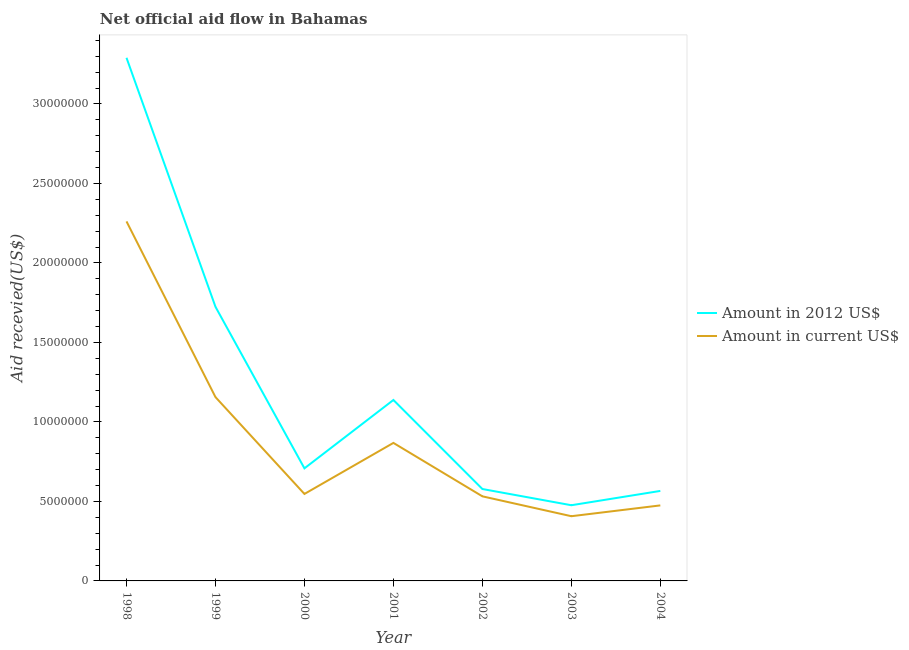Is the number of lines equal to the number of legend labels?
Keep it short and to the point. Yes. What is the amount of aid received(expressed in us$) in 2003?
Keep it short and to the point. 4.07e+06. Across all years, what is the maximum amount of aid received(expressed in 2012 us$)?
Offer a terse response. 3.29e+07. Across all years, what is the minimum amount of aid received(expressed in us$)?
Your answer should be compact. 4.07e+06. In which year was the amount of aid received(expressed in us$) maximum?
Your answer should be very brief. 1998. What is the total amount of aid received(expressed in us$) in the graph?
Provide a succinct answer. 6.25e+07. What is the difference between the amount of aid received(expressed in us$) in 1999 and that in 2004?
Provide a short and direct response. 6.81e+06. What is the difference between the amount of aid received(expressed in 2012 us$) in 1998 and the amount of aid received(expressed in us$) in 2002?
Offer a very short reply. 2.76e+07. What is the average amount of aid received(expressed in 2012 us$) per year?
Your answer should be compact. 1.21e+07. In the year 2001, what is the difference between the amount of aid received(expressed in us$) and amount of aid received(expressed in 2012 us$)?
Your response must be concise. -2.70e+06. What is the ratio of the amount of aid received(expressed in 2012 us$) in 1998 to that in 2002?
Ensure brevity in your answer.  5.69. Is the difference between the amount of aid received(expressed in us$) in 2000 and 2002 greater than the difference between the amount of aid received(expressed in 2012 us$) in 2000 and 2002?
Make the answer very short. No. What is the difference between the highest and the second highest amount of aid received(expressed in us$)?
Make the answer very short. 1.10e+07. What is the difference between the highest and the lowest amount of aid received(expressed in 2012 us$)?
Keep it short and to the point. 2.81e+07. In how many years, is the amount of aid received(expressed in 2012 us$) greater than the average amount of aid received(expressed in 2012 us$) taken over all years?
Provide a succinct answer. 2. Is the sum of the amount of aid received(expressed in us$) in 1998 and 2003 greater than the maximum amount of aid received(expressed in 2012 us$) across all years?
Keep it short and to the point. No. Is the amount of aid received(expressed in us$) strictly less than the amount of aid received(expressed in 2012 us$) over the years?
Make the answer very short. Yes. What is the difference between two consecutive major ticks on the Y-axis?
Make the answer very short. 5.00e+06. Does the graph contain any zero values?
Your answer should be very brief. No. Where does the legend appear in the graph?
Provide a short and direct response. Center right. What is the title of the graph?
Ensure brevity in your answer.  Net official aid flow in Bahamas. What is the label or title of the X-axis?
Offer a very short reply. Year. What is the label or title of the Y-axis?
Provide a succinct answer. Aid recevied(US$). What is the Aid recevied(US$) of Amount in 2012 US$ in 1998?
Your answer should be compact. 3.29e+07. What is the Aid recevied(US$) of Amount in current US$ in 1998?
Give a very brief answer. 2.26e+07. What is the Aid recevied(US$) of Amount in 2012 US$ in 1999?
Offer a terse response. 1.72e+07. What is the Aid recevied(US$) in Amount in current US$ in 1999?
Your answer should be very brief. 1.16e+07. What is the Aid recevied(US$) of Amount in 2012 US$ in 2000?
Make the answer very short. 7.08e+06. What is the Aid recevied(US$) of Amount in current US$ in 2000?
Your response must be concise. 5.47e+06. What is the Aid recevied(US$) in Amount in 2012 US$ in 2001?
Ensure brevity in your answer.  1.14e+07. What is the Aid recevied(US$) of Amount in current US$ in 2001?
Make the answer very short. 8.68e+06. What is the Aid recevied(US$) in Amount in 2012 US$ in 2002?
Your answer should be very brief. 5.78e+06. What is the Aid recevied(US$) of Amount in current US$ in 2002?
Your answer should be compact. 5.32e+06. What is the Aid recevied(US$) of Amount in 2012 US$ in 2003?
Ensure brevity in your answer.  4.76e+06. What is the Aid recevied(US$) in Amount in current US$ in 2003?
Provide a short and direct response. 4.07e+06. What is the Aid recevied(US$) in Amount in 2012 US$ in 2004?
Provide a short and direct response. 5.66e+06. What is the Aid recevied(US$) in Amount in current US$ in 2004?
Your answer should be very brief. 4.75e+06. Across all years, what is the maximum Aid recevied(US$) in Amount in 2012 US$?
Provide a succinct answer. 3.29e+07. Across all years, what is the maximum Aid recevied(US$) in Amount in current US$?
Give a very brief answer. 2.26e+07. Across all years, what is the minimum Aid recevied(US$) of Amount in 2012 US$?
Keep it short and to the point. 4.76e+06. Across all years, what is the minimum Aid recevied(US$) of Amount in current US$?
Offer a very short reply. 4.07e+06. What is the total Aid recevied(US$) of Amount in 2012 US$ in the graph?
Keep it short and to the point. 8.48e+07. What is the total Aid recevied(US$) in Amount in current US$ in the graph?
Make the answer very short. 6.25e+07. What is the difference between the Aid recevied(US$) of Amount in 2012 US$ in 1998 and that in 1999?
Your response must be concise. 1.57e+07. What is the difference between the Aid recevied(US$) of Amount in current US$ in 1998 and that in 1999?
Make the answer very short. 1.10e+07. What is the difference between the Aid recevied(US$) in Amount in 2012 US$ in 1998 and that in 2000?
Offer a terse response. 2.58e+07. What is the difference between the Aid recevied(US$) of Amount in current US$ in 1998 and that in 2000?
Offer a very short reply. 1.71e+07. What is the difference between the Aid recevied(US$) of Amount in 2012 US$ in 1998 and that in 2001?
Give a very brief answer. 2.15e+07. What is the difference between the Aid recevied(US$) in Amount in current US$ in 1998 and that in 2001?
Provide a short and direct response. 1.39e+07. What is the difference between the Aid recevied(US$) in Amount in 2012 US$ in 1998 and that in 2002?
Offer a very short reply. 2.71e+07. What is the difference between the Aid recevied(US$) in Amount in current US$ in 1998 and that in 2002?
Keep it short and to the point. 1.73e+07. What is the difference between the Aid recevied(US$) in Amount in 2012 US$ in 1998 and that in 2003?
Provide a succinct answer. 2.81e+07. What is the difference between the Aid recevied(US$) in Amount in current US$ in 1998 and that in 2003?
Make the answer very short. 1.85e+07. What is the difference between the Aid recevied(US$) of Amount in 2012 US$ in 1998 and that in 2004?
Make the answer very short. 2.72e+07. What is the difference between the Aid recevied(US$) in Amount in current US$ in 1998 and that in 2004?
Your response must be concise. 1.79e+07. What is the difference between the Aid recevied(US$) of Amount in 2012 US$ in 1999 and that in 2000?
Provide a short and direct response. 1.02e+07. What is the difference between the Aid recevied(US$) of Amount in current US$ in 1999 and that in 2000?
Keep it short and to the point. 6.09e+06. What is the difference between the Aid recevied(US$) of Amount in 2012 US$ in 1999 and that in 2001?
Make the answer very short. 5.86e+06. What is the difference between the Aid recevied(US$) in Amount in current US$ in 1999 and that in 2001?
Provide a short and direct response. 2.88e+06. What is the difference between the Aid recevied(US$) in Amount in 2012 US$ in 1999 and that in 2002?
Keep it short and to the point. 1.15e+07. What is the difference between the Aid recevied(US$) of Amount in current US$ in 1999 and that in 2002?
Offer a very short reply. 6.24e+06. What is the difference between the Aid recevied(US$) of Amount in 2012 US$ in 1999 and that in 2003?
Your answer should be very brief. 1.25e+07. What is the difference between the Aid recevied(US$) of Amount in current US$ in 1999 and that in 2003?
Provide a succinct answer. 7.49e+06. What is the difference between the Aid recevied(US$) of Amount in 2012 US$ in 1999 and that in 2004?
Ensure brevity in your answer.  1.16e+07. What is the difference between the Aid recevied(US$) in Amount in current US$ in 1999 and that in 2004?
Provide a short and direct response. 6.81e+06. What is the difference between the Aid recevied(US$) of Amount in 2012 US$ in 2000 and that in 2001?
Offer a terse response. -4.30e+06. What is the difference between the Aid recevied(US$) in Amount in current US$ in 2000 and that in 2001?
Ensure brevity in your answer.  -3.21e+06. What is the difference between the Aid recevied(US$) of Amount in 2012 US$ in 2000 and that in 2002?
Give a very brief answer. 1.30e+06. What is the difference between the Aid recevied(US$) of Amount in 2012 US$ in 2000 and that in 2003?
Offer a terse response. 2.32e+06. What is the difference between the Aid recevied(US$) in Amount in current US$ in 2000 and that in 2003?
Provide a succinct answer. 1.40e+06. What is the difference between the Aid recevied(US$) of Amount in 2012 US$ in 2000 and that in 2004?
Your answer should be very brief. 1.42e+06. What is the difference between the Aid recevied(US$) in Amount in current US$ in 2000 and that in 2004?
Your answer should be very brief. 7.20e+05. What is the difference between the Aid recevied(US$) in Amount in 2012 US$ in 2001 and that in 2002?
Your answer should be compact. 5.60e+06. What is the difference between the Aid recevied(US$) in Amount in current US$ in 2001 and that in 2002?
Your answer should be very brief. 3.36e+06. What is the difference between the Aid recevied(US$) of Amount in 2012 US$ in 2001 and that in 2003?
Provide a short and direct response. 6.62e+06. What is the difference between the Aid recevied(US$) in Amount in current US$ in 2001 and that in 2003?
Your answer should be very brief. 4.61e+06. What is the difference between the Aid recevied(US$) of Amount in 2012 US$ in 2001 and that in 2004?
Your answer should be compact. 5.72e+06. What is the difference between the Aid recevied(US$) of Amount in current US$ in 2001 and that in 2004?
Offer a terse response. 3.93e+06. What is the difference between the Aid recevied(US$) in Amount in 2012 US$ in 2002 and that in 2003?
Provide a short and direct response. 1.02e+06. What is the difference between the Aid recevied(US$) in Amount in current US$ in 2002 and that in 2003?
Keep it short and to the point. 1.25e+06. What is the difference between the Aid recevied(US$) of Amount in 2012 US$ in 2002 and that in 2004?
Make the answer very short. 1.20e+05. What is the difference between the Aid recevied(US$) in Amount in current US$ in 2002 and that in 2004?
Your response must be concise. 5.70e+05. What is the difference between the Aid recevied(US$) in Amount in 2012 US$ in 2003 and that in 2004?
Your answer should be very brief. -9.00e+05. What is the difference between the Aid recevied(US$) of Amount in current US$ in 2003 and that in 2004?
Keep it short and to the point. -6.80e+05. What is the difference between the Aid recevied(US$) of Amount in 2012 US$ in 1998 and the Aid recevied(US$) of Amount in current US$ in 1999?
Your answer should be very brief. 2.13e+07. What is the difference between the Aid recevied(US$) of Amount in 2012 US$ in 1998 and the Aid recevied(US$) of Amount in current US$ in 2000?
Provide a succinct answer. 2.74e+07. What is the difference between the Aid recevied(US$) of Amount in 2012 US$ in 1998 and the Aid recevied(US$) of Amount in current US$ in 2001?
Ensure brevity in your answer.  2.42e+07. What is the difference between the Aid recevied(US$) of Amount in 2012 US$ in 1998 and the Aid recevied(US$) of Amount in current US$ in 2002?
Your answer should be compact. 2.76e+07. What is the difference between the Aid recevied(US$) of Amount in 2012 US$ in 1998 and the Aid recevied(US$) of Amount in current US$ in 2003?
Make the answer very short. 2.88e+07. What is the difference between the Aid recevied(US$) in Amount in 2012 US$ in 1998 and the Aid recevied(US$) in Amount in current US$ in 2004?
Keep it short and to the point. 2.82e+07. What is the difference between the Aid recevied(US$) of Amount in 2012 US$ in 1999 and the Aid recevied(US$) of Amount in current US$ in 2000?
Offer a very short reply. 1.18e+07. What is the difference between the Aid recevied(US$) in Amount in 2012 US$ in 1999 and the Aid recevied(US$) in Amount in current US$ in 2001?
Your answer should be very brief. 8.56e+06. What is the difference between the Aid recevied(US$) of Amount in 2012 US$ in 1999 and the Aid recevied(US$) of Amount in current US$ in 2002?
Your response must be concise. 1.19e+07. What is the difference between the Aid recevied(US$) in Amount in 2012 US$ in 1999 and the Aid recevied(US$) in Amount in current US$ in 2003?
Ensure brevity in your answer.  1.32e+07. What is the difference between the Aid recevied(US$) of Amount in 2012 US$ in 1999 and the Aid recevied(US$) of Amount in current US$ in 2004?
Keep it short and to the point. 1.25e+07. What is the difference between the Aid recevied(US$) of Amount in 2012 US$ in 2000 and the Aid recevied(US$) of Amount in current US$ in 2001?
Make the answer very short. -1.60e+06. What is the difference between the Aid recevied(US$) of Amount in 2012 US$ in 2000 and the Aid recevied(US$) of Amount in current US$ in 2002?
Ensure brevity in your answer.  1.76e+06. What is the difference between the Aid recevied(US$) of Amount in 2012 US$ in 2000 and the Aid recevied(US$) of Amount in current US$ in 2003?
Make the answer very short. 3.01e+06. What is the difference between the Aid recevied(US$) of Amount in 2012 US$ in 2000 and the Aid recevied(US$) of Amount in current US$ in 2004?
Make the answer very short. 2.33e+06. What is the difference between the Aid recevied(US$) of Amount in 2012 US$ in 2001 and the Aid recevied(US$) of Amount in current US$ in 2002?
Offer a very short reply. 6.06e+06. What is the difference between the Aid recevied(US$) of Amount in 2012 US$ in 2001 and the Aid recevied(US$) of Amount in current US$ in 2003?
Offer a very short reply. 7.31e+06. What is the difference between the Aid recevied(US$) of Amount in 2012 US$ in 2001 and the Aid recevied(US$) of Amount in current US$ in 2004?
Give a very brief answer. 6.63e+06. What is the difference between the Aid recevied(US$) of Amount in 2012 US$ in 2002 and the Aid recevied(US$) of Amount in current US$ in 2003?
Provide a short and direct response. 1.71e+06. What is the difference between the Aid recevied(US$) of Amount in 2012 US$ in 2002 and the Aid recevied(US$) of Amount in current US$ in 2004?
Offer a very short reply. 1.03e+06. What is the average Aid recevied(US$) of Amount in 2012 US$ per year?
Keep it short and to the point. 1.21e+07. What is the average Aid recevied(US$) of Amount in current US$ per year?
Keep it short and to the point. 8.92e+06. In the year 1998, what is the difference between the Aid recevied(US$) of Amount in 2012 US$ and Aid recevied(US$) of Amount in current US$?
Ensure brevity in your answer.  1.03e+07. In the year 1999, what is the difference between the Aid recevied(US$) of Amount in 2012 US$ and Aid recevied(US$) of Amount in current US$?
Your answer should be compact. 5.68e+06. In the year 2000, what is the difference between the Aid recevied(US$) of Amount in 2012 US$ and Aid recevied(US$) of Amount in current US$?
Provide a short and direct response. 1.61e+06. In the year 2001, what is the difference between the Aid recevied(US$) in Amount in 2012 US$ and Aid recevied(US$) in Amount in current US$?
Your answer should be compact. 2.70e+06. In the year 2003, what is the difference between the Aid recevied(US$) of Amount in 2012 US$ and Aid recevied(US$) of Amount in current US$?
Your answer should be very brief. 6.90e+05. In the year 2004, what is the difference between the Aid recevied(US$) in Amount in 2012 US$ and Aid recevied(US$) in Amount in current US$?
Offer a very short reply. 9.10e+05. What is the ratio of the Aid recevied(US$) of Amount in 2012 US$ in 1998 to that in 1999?
Your response must be concise. 1.91. What is the ratio of the Aid recevied(US$) of Amount in current US$ in 1998 to that in 1999?
Keep it short and to the point. 1.96. What is the ratio of the Aid recevied(US$) of Amount in 2012 US$ in 1998 to that in 2000?
Keep it short and to the point. 4.65. What is the ratio of the Aid recevied(US$) of Amount in current US$ in 1998 to that in 2000?
Offer a terse response. 4.13. What is the ratio of the Aid recevied(US$) of Amount in 2012 US$ in 1998 to that in 2001?
Keep it short and to the point. 2.89. What is the ratio of the Aid recevied(US$) in Amount in current US$ in 1998 to that in 2001?
Your response must be concise. 2.6. What is the ratio of the Aid recevied(US$) of Amount in 2012 US$ in 1998 to that in 2002?
Offer a terse response. 5.69. What is the ratio of the Aid recevied(US$) in Amount in current US$ in 1998 to that in 2002?
Ensure brevity in your answer.  4.25. What is the ratio of the Aid recevied(US$) in Amount in 2012 US$ in 1998 to that in 2003?
Your answer should be very brief. 6.91. What is the ratio of the Aid recevied(US$) of Amount in current US$ in 1998 to that in 2003?
Your answer should be compact. 5.56. What is the ratio of the Aid recevied(US$) of Amount in 2012 US$ in 1998 to that in 2004?
Provide a short and direct response. 5.81. What is the ratio of the Aid recevied(US$) of Amount in current US$ in 1998 to that in 2004?
Your response must be concise. 4.76. What is the ratio of the Aid recevied(US$) in Amount in 2012 US$ in 1999 to that in 2000?
Provide a succinct answer. 2.44. What is the ratio of the Aid recevied(US$) in Amount in current US$ in 1999 to that in 2000?
Your answer should be very brief. 2.11. What is the ratio of the Aid recevied(US$) of Amount in 2012 US$ in 1999 to that in 2001?
Provide a succinct answer. 1.51. What is the ratio of the Aid recevied(US$) in Amount in current US$ in 1999 to that in 2001?
Provide a short and direct response. 1.33. What is the ratio of the Aid recevied(US$) in Amount in 2012 US$ in 1999 to that in 2002?
Provide a short and direct response. 2.98. What is the ratio of the Aid recevied(US$) of Amount in current US$ in 1999 to that in 2002?
Your response must be concise. 2.17. What is the ratio of the Aid recevied(US$) in Amount in 2012 US$ in 1999 to that in 2003?
Offer a very short reply. 3.62. What is the ratio of the Aid recevied(US$) of Amount in current US$ in 1999 to that in 2003?
Make the answer very short. 2.84. What is the ratio of the Aid recevied(US$) of Amount in 2012 US$ in 1999 to that in 2004?
Your answer should be compact. 3.05. What is the ratio of the Aid recevied(US$) in Amount in current US$ in 1999 to that in 2004?
Your answer should be very brief. 2.43. What is the ratio of the Aid recevied(US$) of Amount in 2012 US$ in 2000 to that in 2001?
Ensure brevity in your answer.  0.62. What is the ratio of the Aid recevied(US$) in Amount in current US$ in 2000 to that in 2001?
Offer a terse response. 0.63. What is the ratio of the Aid recevied(US$) of Amount in 2012 US$ in 2000 to that in 2002?
Your response must be concise. 1.22. What is the ratio of the Aid recevied(US$) of Amount in current US$ in 2000 to that in 2002?
Your answer should be very brief. 1.03. What is the ratio of the Aid recevied(US$) of Amount in 2012 US$ in 2000 to that in 2003?
Your answer should be compact. 1.49. What is the ratio of the Aid recevied(US$) of Amount in current US$ in 2000 to that in 2003?
Keep it short and to the point. 1.34. What is the ratio of the Aid recevied(US$) of Amount in 2012 US$ in 2000 to that in 2004?
Your answer should be very brief. 1.25. What is the ratio of the Aid recevied(US$) of Amount in current US$ in 2000 to that in 2004?
Offer a very short reply. 1.15. What is the ratio of the Aid recevied(US$) of Amount in 2012 US$ in 2001 to that in 2002?
Your answer should be very brief. 1.97. What is the ratio of the Aid recevied(US$) in Amount in current US$ in 2001 to that in 2002?
Your answer should be very brief. 1.63. What is the ratio of the Aid recevied(US$) in Amount in 2012 US$ in 2001 to that in 2003?
Offer a very short reply. 2.39. What is the ratio of the Aid recevied(US$) in Amount in current US$ in 2001 to that in 2003?
Provide a short and direct response. 2.13. What is the ratio of the Aid recevied(US$) of Amount in 2012 US$ in 2001 to that in 2004?
Your response must be concise. 2.01. What is the ratio of the Aid recevied(US$) in Amount in current US$ in 2001 to that in 2004?
Your answer should be compact. 1.83. What is the ratio of the Aid recevied(US$) of Amount in 2012 US$ in 2002 to that in 2003?
Ensure brevity in your answer.  1.21. What is the ratio of the Aid recevied(US$) in Amount in current US$ in 2002 to that in 2003?
Give a very brief answer. 1.31. What is the ratio of the Aid recevied(US$) of Amount in 2012 US$ in 2002 to that in 2004?
Make the answer very short. 1.02. What is the ratio of the Aid recevied(US$) of Amount in current US$ in 2002 to that in 2004?
Provide a succinct answer. 1.12. What is the ratio of the Aid recevied(US$) in Amount in 2012 US$ in 2003 to that in 2004?
Your answer should be very brief. 0.84. What is the ratio of the Aid recevied(US$) of Amount in current US$ in 2003 to that in 2004?
Make the answer very short. 0.86. What is the difference between the highest and the second highest Aid recevied(US$) in Amount in 2012 US$?
Make the answer very short. 1.57e+07. What is the difference between the highest and the second highest Aid recevied(US$) of Amount in current US$?
Your answer should be very brief. 1.10e+07. What is the difference between the highest and the lowest Aid recevied(US$) of Amount in 2012 US$?
Offer a terse response. 2.81e+07. What is the difference between the highest and the lowest Aid recevied(US$) in Amount in current US$?
Provide a succinct answer. 1.85e+07. 